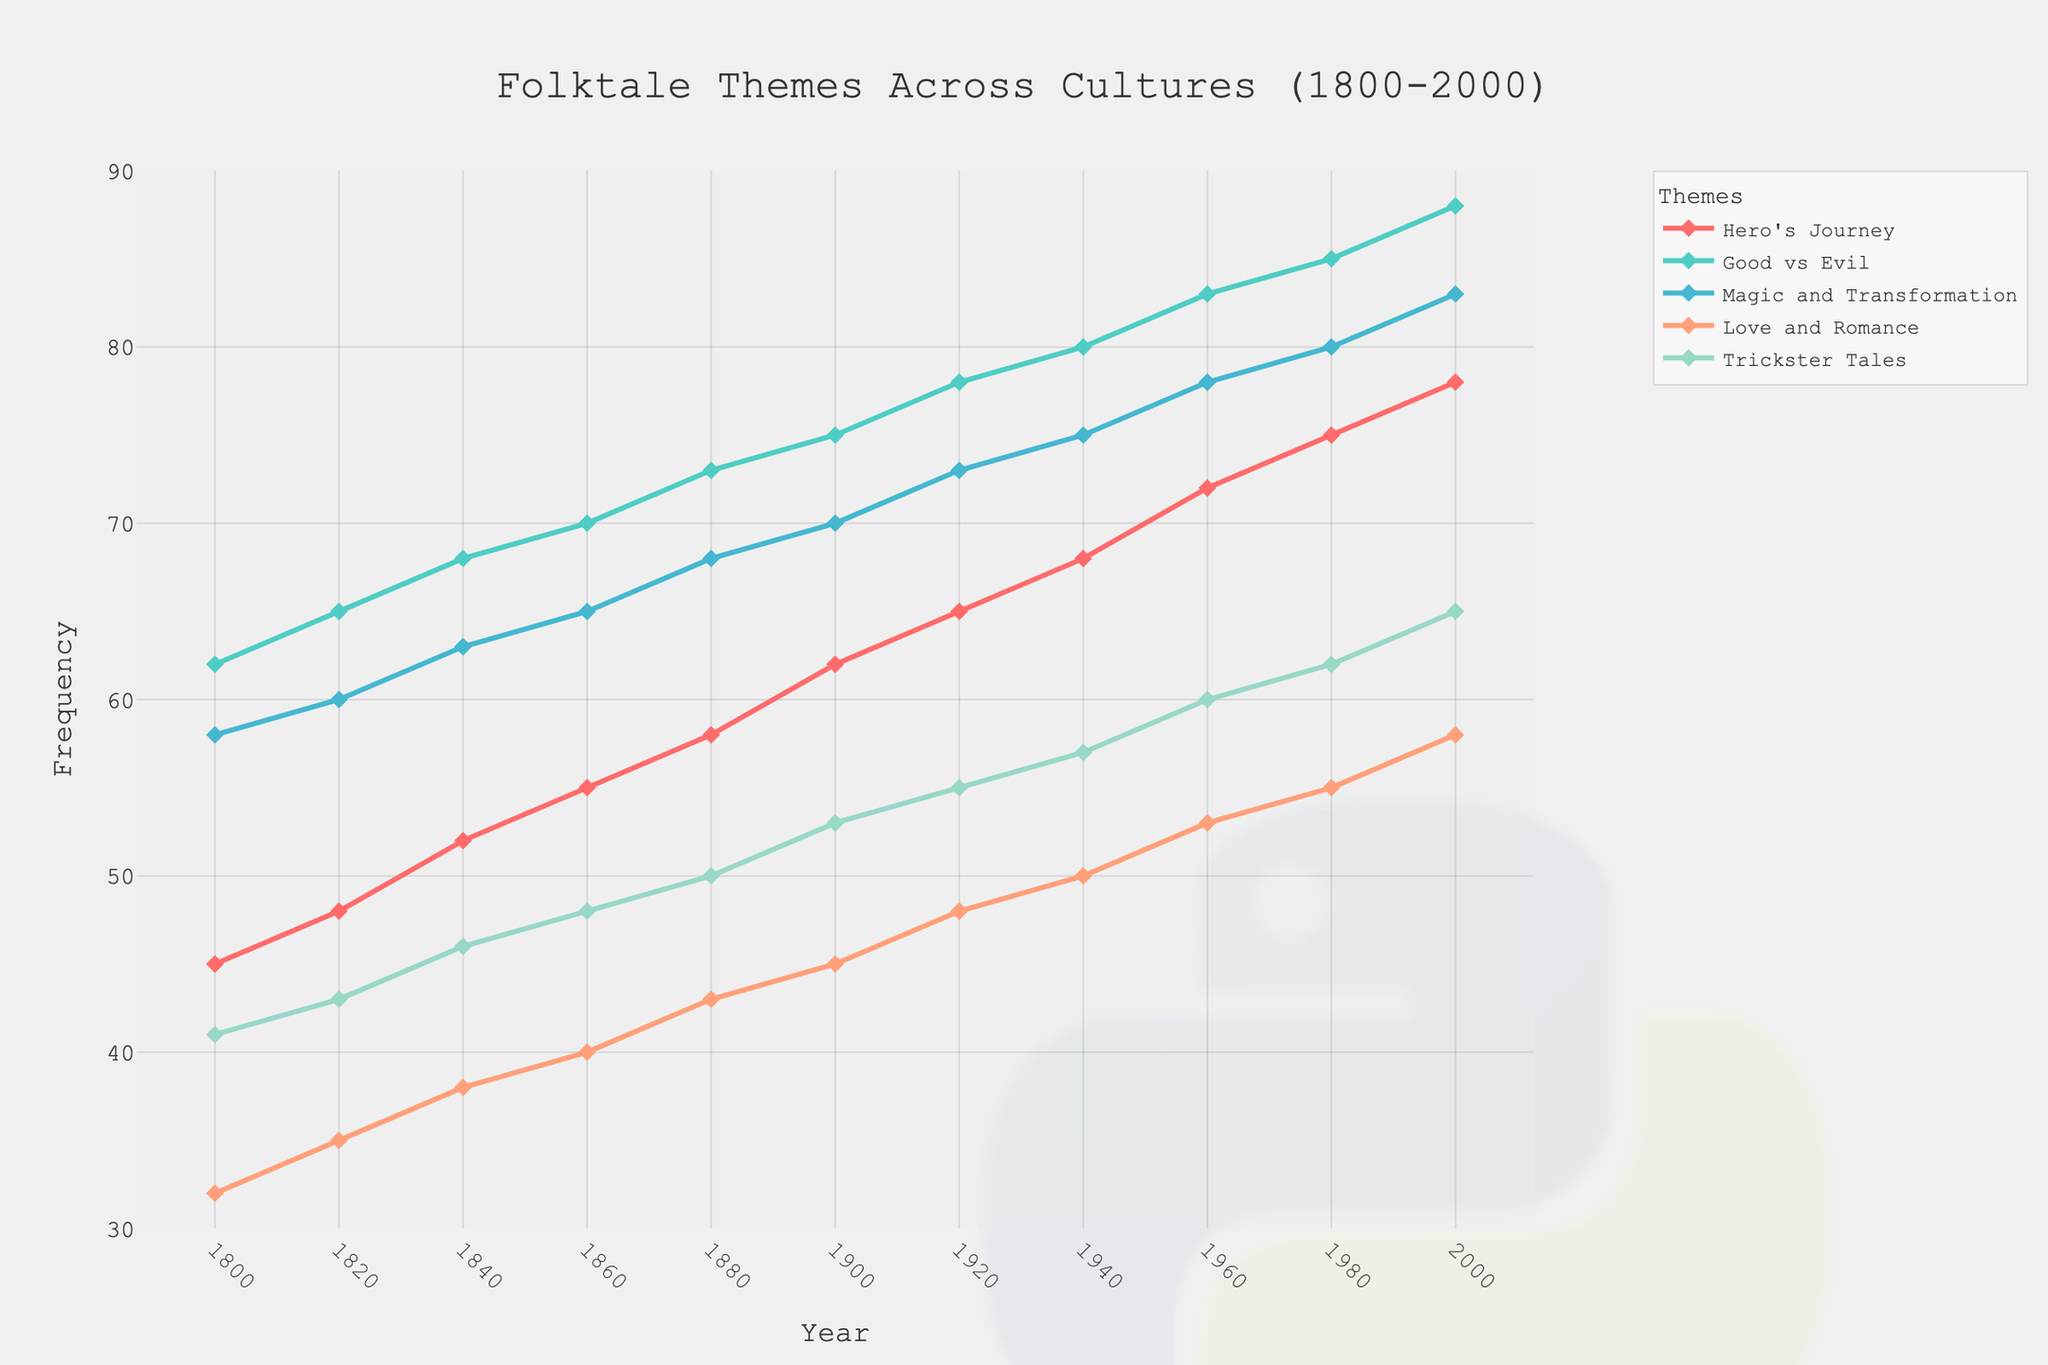What theme has the highest frequency in the year 2000? Look at the data for the year 2000 and identify which theme has the highest value. The highest value is 88 for the theme "Good vs Evil."
Answer: Good vs Evil How did the frequency of "Hero's Journey" change from 1800 to 2000? To determine the change, subtract the frequency in 1800 from the frequency in 2000. The value in 2000 is 78 and in 1800 is 45, so the difference is 78 - 45 = 33.
Answer: Increased by 33 Which theme saw the smallest increase in frequency from 1800 to 2000? Calculate the increase for each theme from 1800 to 2000 and identify the smallest. Increases: Hero's Journey (78-45=33), Good vs Evil (88-62=26), Magic and Transformation (83-58=25), Love and Romance (58-32=26), Trickster Tales (65-41=24). The smallest increase is 24 for "Trickster Tales."
Answer: Trickster Tales What is the average frequency of "Magic and Transformation" over the years 1800, 1900, and 2000? Sum the frequencies for "Magic and Transformation" in the years 1800, 1900, and 2000, then divide by 3: (58 + 70 + 83) / 3 = 211 / 3 ≈ 70.33.
Answer: 70.33 By how much does "Love and Romance" frequency exceed "Trickster Tales" in 2000? Subtract the frequency of "Trickster Tales" from "Love and Romance" in the year 2000: 58 - 65 = -7.
Answer: -7 What is the trend in the frequency of "Good vs Evil" from 1800 to 2000? Observe the frequency values at different years for "Good vs Evil." It consistently increases from 62 in 1800 to 88 in 2000.
Answer: Increasing Which folktale theme had the most stable frequency trend over the years? Compare the frequency changes of all themes and determine the one with the least deviation. "Trickster Tales" has the most consistent, gradual increase.
Answer: Trickster Tales Is the gap between "Hero's Journey" and "Magic and Transformation" larger in 1800 or in 2000? Calculate the difference between the frequencies of "Hero's Journey" and "Magic and Transformation" for both years. In 1800: 58 - 45 = 13. In 2000: 83 - 78 = 5. The gap is larger in 1800.
Answer: 1800 What is the total frequency for all themes combined in 1940? Sum the frequencies for all themes in 1940: Hero's Journey (68), Good vs Evil (80), Magic and Transformation (75), Love and Romance (50), Trickster Tales (57). Total = 68 + 80 + 75 + 50 + 57 = 330.
Answer: 330 